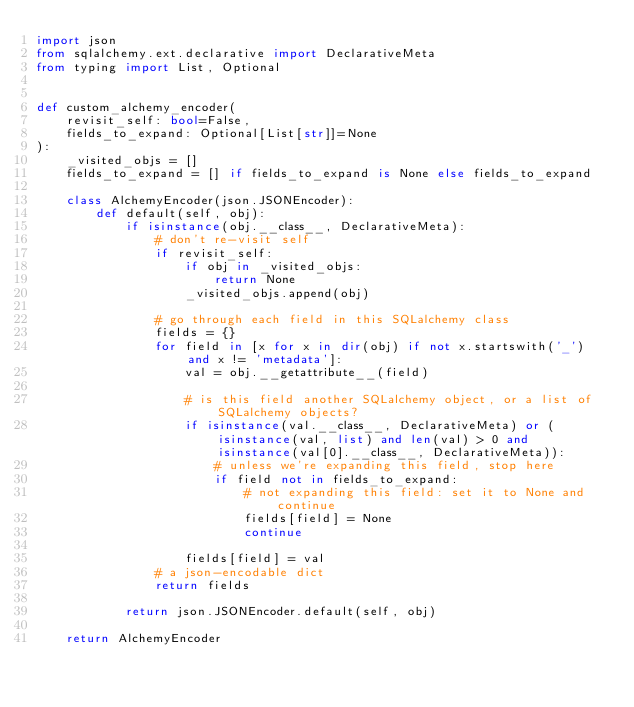<code> <loc_0><loc_0><loc_500><loc_500><_Python_>import json
from sqlalchemy.ext.declarative import DeclarativeMeta
from typing import List, Optional


def custom_alchemy_encoder(
    revisit_self: bool=False,
    fields_to_expand: Optional[List[str]]=None
):
    _visited_objs = []
    fields_to_expand = [] if fields_to_expand is None else fields_to_expand

    class AlchemyEncoder(json.JSONEncoder):
        def default(self, obj):
            if isinstance(obj.__class__, DeclarativeMeta):
                # don't re-visit self
                if revisit_self:
                    if obj in _visited_objs:
                        return None
                    _visited_objs.append(obj)

                # go through each field in this SQLalchemy class
                fields = {}
                for field in [x for x in dir(obj) if not x.startswith('_') and x != 'metadata']:
                    val = obj.__getattribute__(field)

                    # is this field another SQLalchemy object, or a list of SQLalchemy objects?
                    if isinstance(val.__class__, DeclarativeMeta) or (isinstance(val, list) and len(val) > 0 and isinstance(val[0].__class__, DeclarativeMeta)):
                        # unless we're expanding this field, stop here
                        if field not in fields_to_expand:
                            # not expanding this field: set it to None and continue
                            fields[field] = None
                            continue

                    fields[field] = val
                # a json-encodable dict
                return fields

            return json.JSONEncoder.default(self, obj)

    return AlchemyEncoder
</code> 